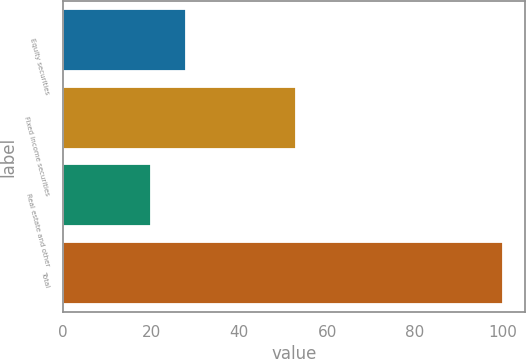Convert chart. <chart><loc_0><loc_0><loc_500><loc_500><bar_chart><fcel>Equity securities<fcel>Fixed income securities<fcel>Real estate and other<fcel>Total<nl><fcel>28<fcel>53<fcel>20<fcel>100<nl></chart> 